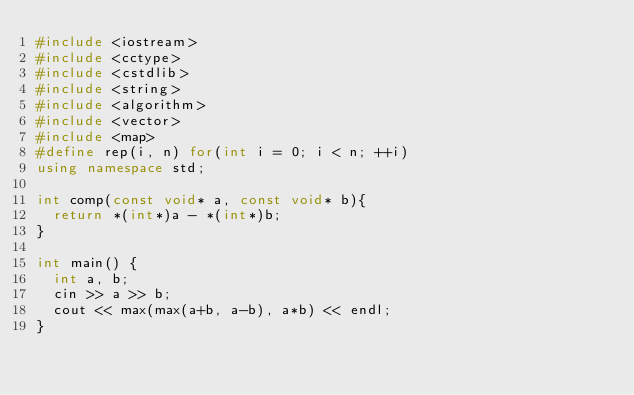<code> <loc_0><loc_0><loc_500><loc_500><_C++_>#include <iostream>
#include <cctype>
#include <cstdlib>
#include <string>
#include <algorithm>
#include <vector>
#include <map>
#define rep(i, n) for(int i = 0; i < n; ++i)
using namespace std;

int comp(const void* a, const void* b){
	return *(int*)a - *(int*)b;
}

int main() {
	int a, b;
	cin >> a >> b;
	cout << max(max(a+b, a-b), a*b) << endl;
}</code> 